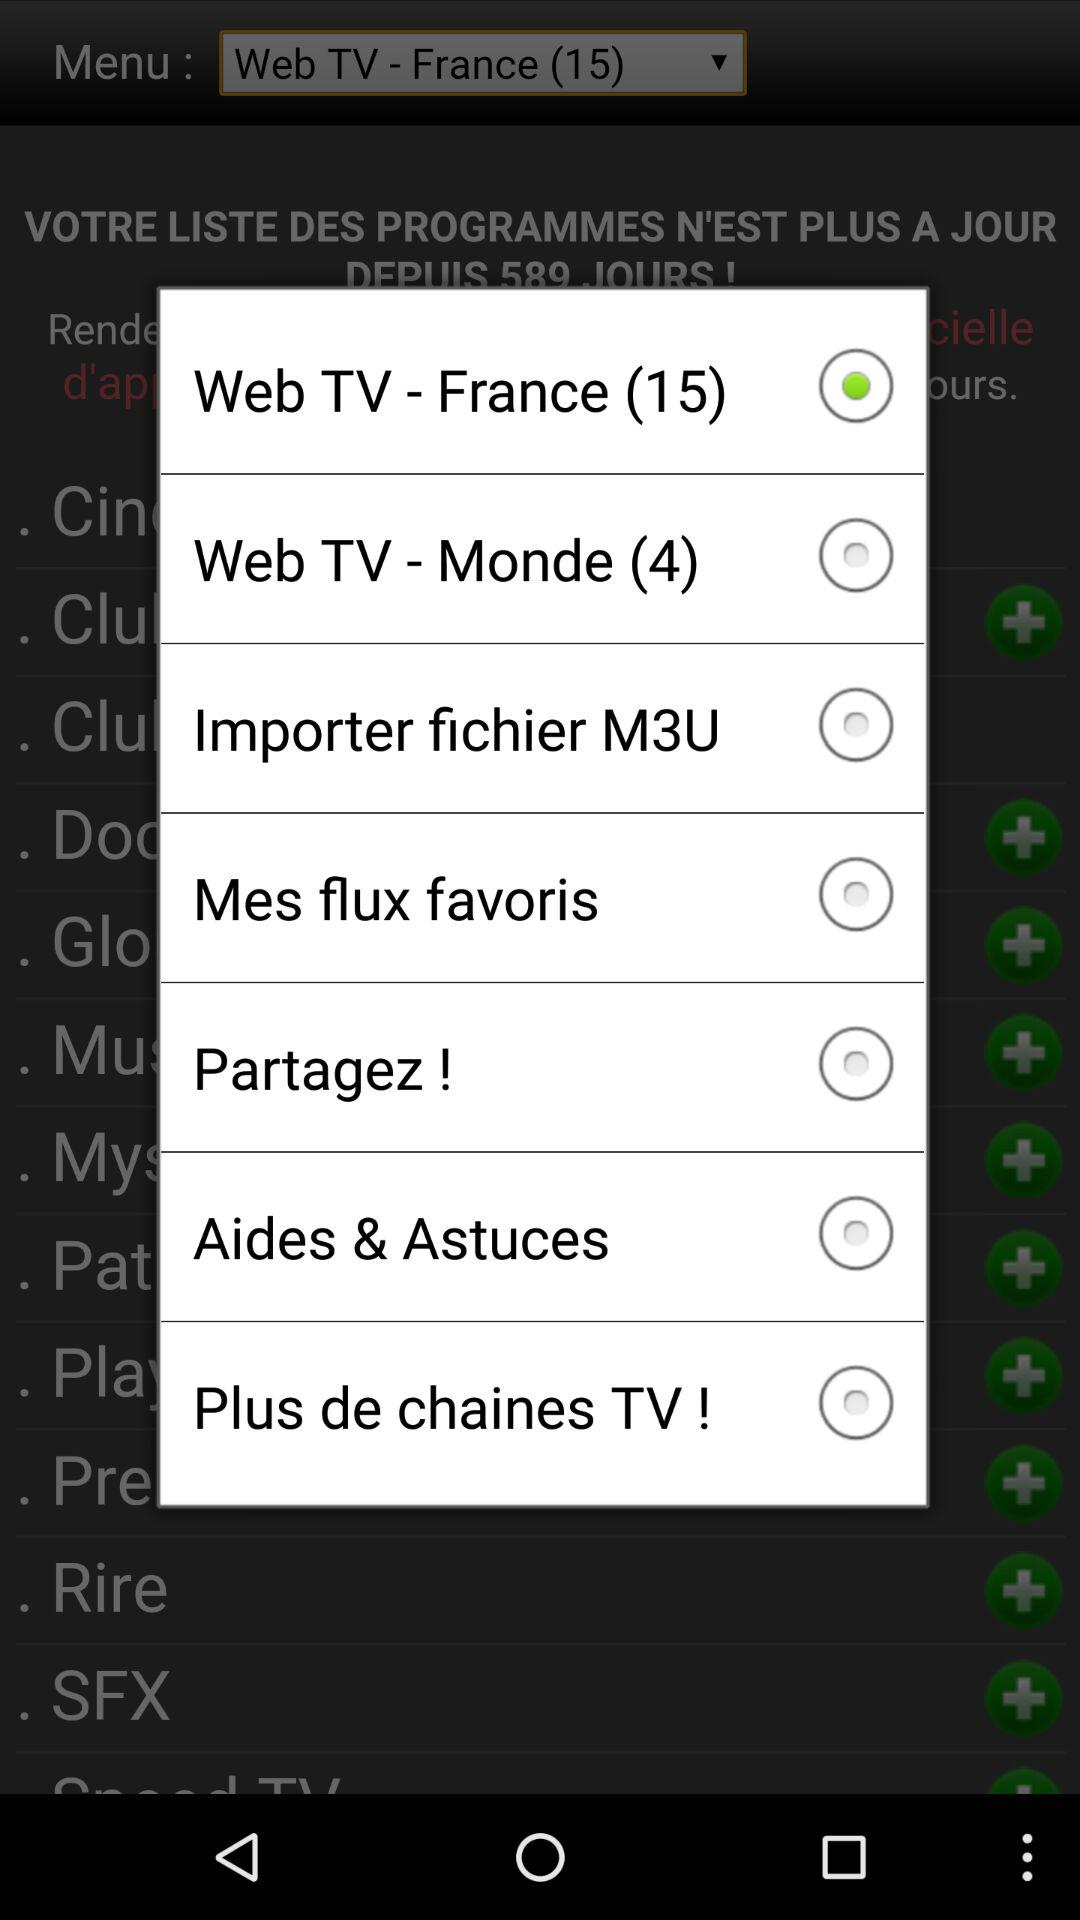How much does "Web TV - France (15)" cost?
When the provided information is insufficient, respond with <no answer>. <no answer> 